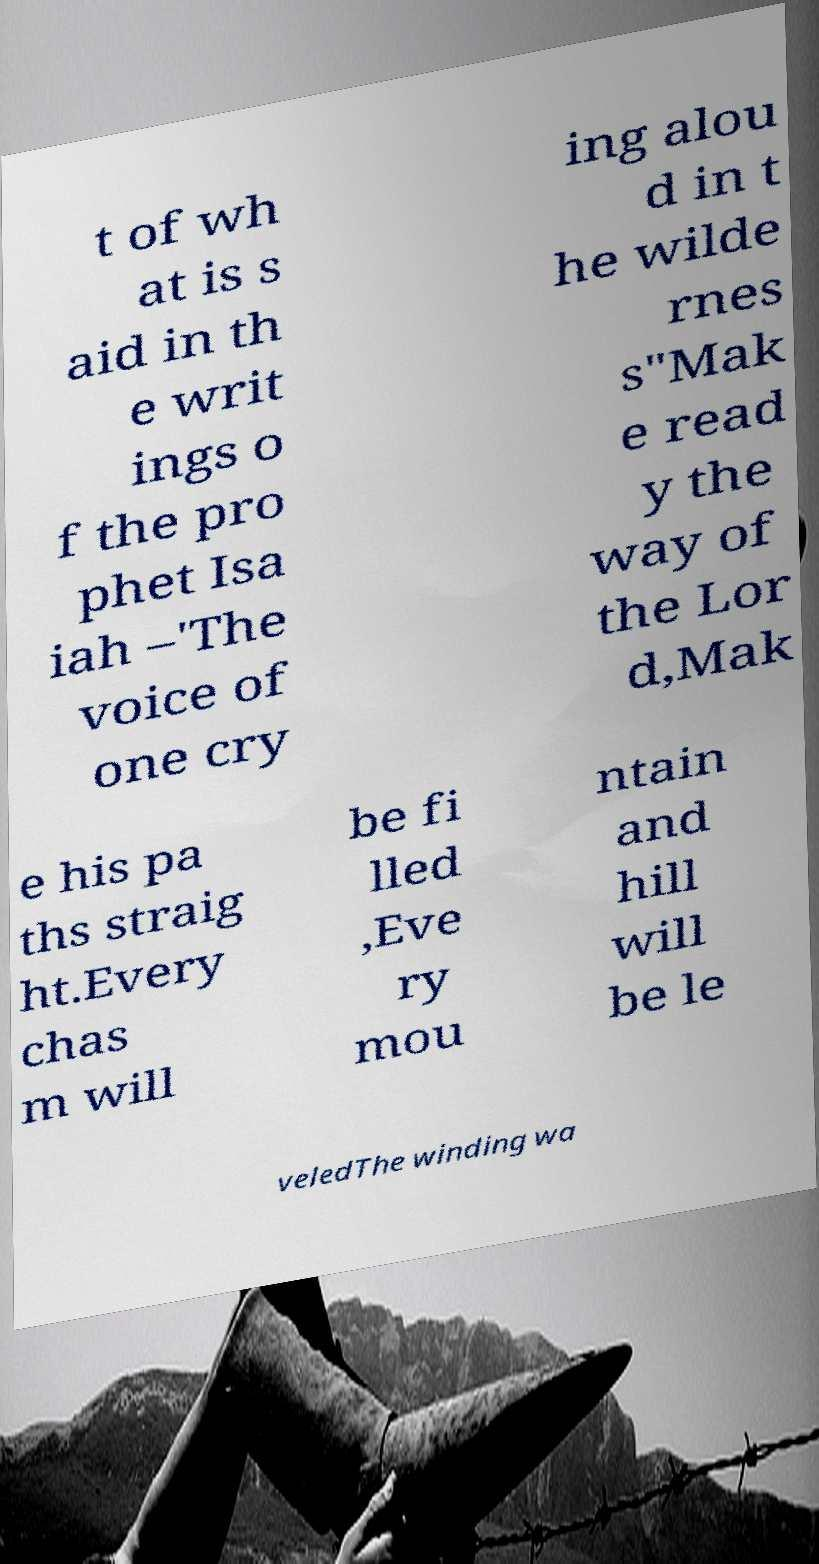Can you read and provide the text displayed in the image?This photo seems to have some interesting text. Can you extract and type it out for me? t of wh at is s aid in th e writ ings o f the pro phet Isa iah –'The voice of one cry ing alou d in t he wilde rnes s"Mak e read y the way of the Lor d,Mak e his pa ths straig ht.Every chas m will be fi lled ,Eve ry mou ntain and hill will be le veledThe winding wa 